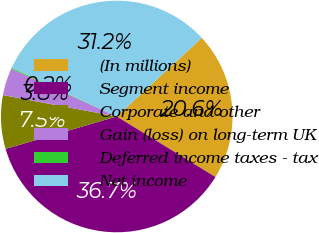Convert chart to OTSL. <chart><loc_0><loc_0><loc_500><loc_500><pie_chart><fcel>(In millions)<fcel>Segment income<fcel>Corporate and other<fcel>Gain (loss) on long-term UK<fcel>Deferred income taxes - tax<fcel>Net income<nl><fcel>20.63%<fcel>36.73%<fcel>7.47%<fcel>3.81%<fcel>0.15%<fcel>31.2%<nl></chart> 